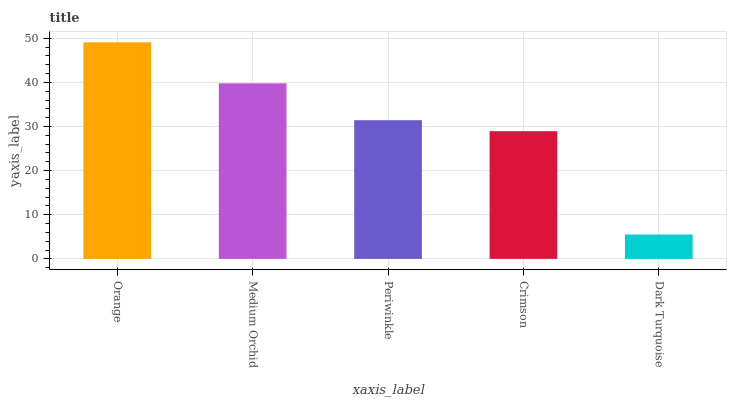Is Dark Turquoise the minimum?
Answer yes or no. Yes. Is Orange the maximum?
Answer yes or no. Yes. Is Medium Orchid the minimum?
Answer yes or no. No. Is Medium Orchid the maximum?
Answer yes or no. No. Is Orange greater than Medium Orchid?
Answer yes or no. Yes. Is Medium Orchid less than Orange?
Answer yes or no. Yes. Is Medium Orchid greater than Orange?
Answer yes or no. No. Is Orange less than Medium Orchid?
Answer yes or no. No. Is Periwinkle the high median?
Answer yes or no. Yes. Is Periwinkle the low median?
Answer yes or no. Yes. Is Orange the high median?
Answer yes or no. No. Is Crimson the low median?
Answer yes or no. No. 